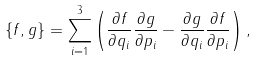<formula> <loc_0><loc_0><loc_500><loc_500>\left \{ f , g \right \} = \sum _ { i = 1 } ^ { 3 } \left ( \frac { \partial f } { \partial q _ { i } } \frac { \partial g } { \partial p _ { i } } - \frac { \partial g } { \partial q _ { i } } \frac { \partial f } { \partial p _ { i } } \right ) ,</formula> 